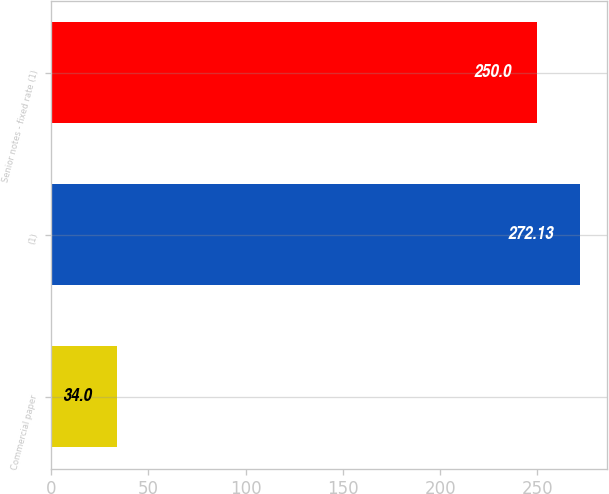Convert chart. <chart><loc_0><loc_0><loc_500><loc_500><bar_chart><fcel>Commercial paper<fcel>(1)<fcel>Senior notes - fixed rate (1)<nl><fcel>34<fcel>272.13<fcel>250<nl></chart> 